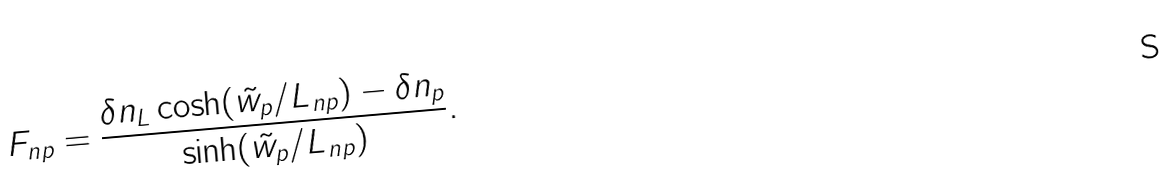<formula> <loc_0><loc_0><loc_500><loc_500>F _ { n p } = \frac { \delta n _ { L } \cosh ( \tilde { w } _ { p } / L _ { n p } ) - \delta n _ { p } } { \sinh ( \tilde { w } _ { p } / L _ { n p } ) } .</formula> 